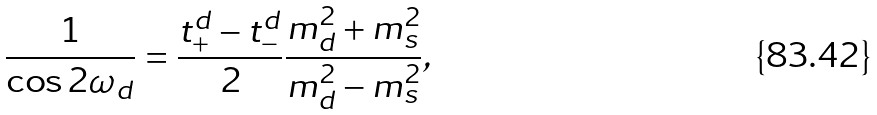<formula> <loc_0><loc_0><loc_500><loc_500>\frac { 1 } { \cos 2 \omega _ { d } } = \frac { t _ { + } ^ { d } - t _ { - } ^ { d } } { 2 } \frac { m _ { d } ^ { 2 } + m _ { s } ^ { 2 } } { m _ { d } ^ { 2 } - m _ { s } ^ { 2 } } ,</formula> 